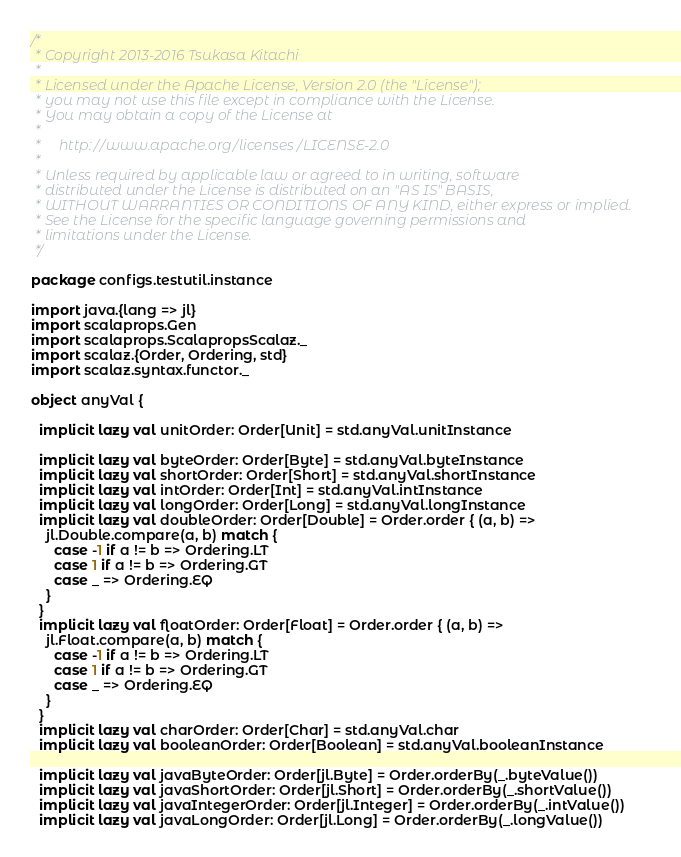<code> <loc_0><loc_0><loc_500><loc_500><_Scala_>/*
 * Copyright 2013-2016 Tsukasa Kitachi
 *
 * Licensed under the Apache License, Version 2.0 (the "License");
 * you may not use this file except in compliance with the License.
 * You may obtain a copy of the License at
 *
 *     http://www.apache.org/licenses/LICENSE-2.0
 *
 * Unless required by applicable law or agreed to in writing, software
 * distributed under the License is distributed on an "AS IS" BASIS,
 * WITHOUT WARRANTIES OR CONDITIONS OF ANY KIND, either express or implied.
 * See the License for the specific language governing permissions and
 * limitations under the License.
 */

package configs.testutil.instance

import java.{lang => jl}
import scalaprops.Gen
import scalaprops.ScalapropsScalaz._
import scalaz.{Order, Ordering, std}
import scalaz.syntax.functor._

object anyVal {

  implicit lazy val unitOrder: Order[Unit] = std.anyVal.unitInstance

  implicit lazy val byteOrder: Order[Byte] = std.anyVal.byteInstance
  implicit lazy val shortOrder: Order[Short] = std.anyVal.shortInstance
  implicit lazy val intOrder: Order[Int] = std.anyVal.intInstance
  implicit lazy val longOrder: Order[Long] = std.anyVal.longInstance
  implicit lazy val doubleOrder: Order[Double] = Order.order { (a, b) =>
    jl.Double.compare(a, b) match {
      case -1 if a != b => Ordering.LT
      case 1 if a != b => Ordering.GT
      case _ => Ordering.EQ
    }
  }
  implicit lazy val floatOrder: Order[Float] = Order.order { (a, b) =>
    jl.Float.compare(a, b) match {
      case -1 if a != b => Ordering.LT
      case 1 if a != b => Ordering.GT
      case _ => Ordering.EQ
    }
  }
  implicit lazy val charOrder: Order[Char] = std.anyVal.char
  implicit lazy val booleanOrder: Order[Boolean] = std.anyVal.booleanInstance

  implicit lazy val javaByteOrder: Order[jl.Byte] = Order.orderBy(_.byteValue())
  implicit lazy val javaShortOrder: Order[jl.Short] = Order.orderBy(_.shortValue())
  implicit lazy val javaIntegerOrder: Order[jl.Integer] = Order.orderBy(_.intValue())
  implicit lazy val javaLongOrder: Order[jl.Long] = Order.orderBy(_.longValue())</code> 